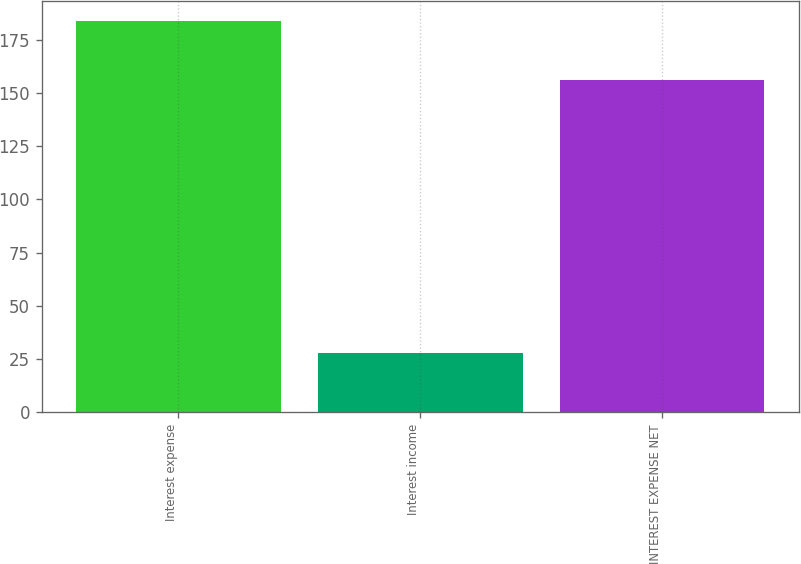<chart> <loc_0><loc_0><loc_500><loc_500><bar_chart><fcel>Interest expense<fcel>Interest income<fcel>INTEREST EXPENSE NET<nl><fcel>184<fcel>28<fcel>156<nl></chart> 